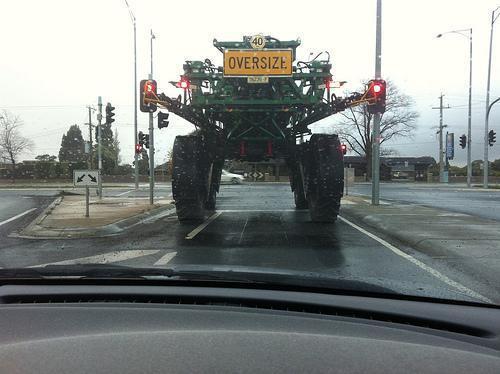How many trucks are there?
Give a very brief answer. 1. 